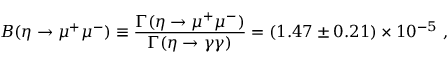<formula> <loc_0><loc_0><loc_500><loc_500>B ( \eta \to \mu ^ { + } \mu ^ { - } ) \equiv \frac { \Gamma ( \eta \to \mu ^ { + } \mu ^ { - } ) } { \Gamma ( \eta \to \gamma \gamma ) } = ( 1 . 4 7 \pm 0 . 2 1 ) \times 1 0 ^ { - 5 } \ ,</formula> 